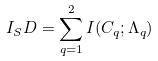<formula> <loc_0><loc_0><loc_500><loc_500>I _ { S } D = \sum _ { q = 1 } ^ { 2 } I ( C _ { q } ; \Lambda _ { q } )</formula> 